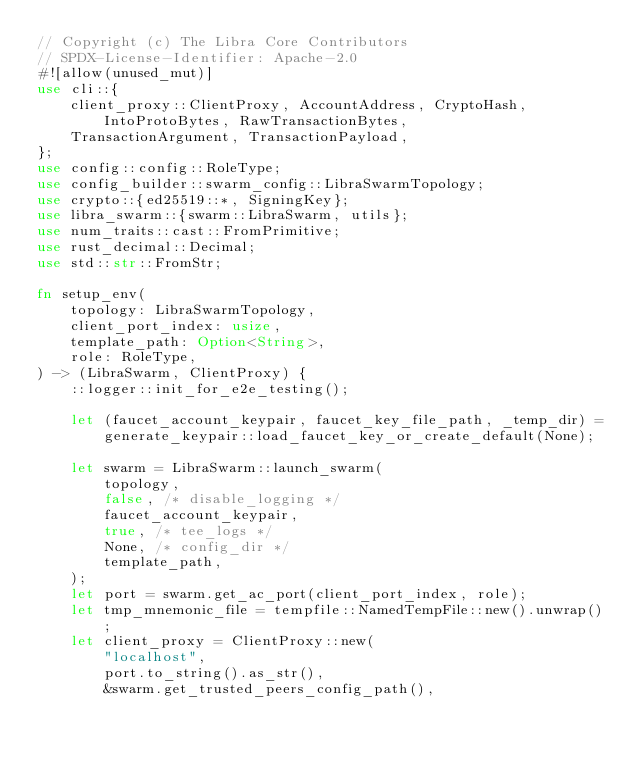<code> <loc_0><loc_0><loc_500><loc_500><_Rust_>// Copyright (c) The Libra Core Contributors
// SPDX-License-Identifier: Apache-2.0
#![allow(unused_mut)]
use cli::{
    client_proxy::ClientProxy, AccountAddress, CryptoHash, IntoProtoBytes, RawTransactionBytes,
    TransactionArgument, TransactionPayload,
};
use config::config::RoleType;
use config_builder::swarm_config::LibraSwarmTopology;
use crypto::{ed25519::*, SigningKey};
use libra_swarm::{swarm::LibraSwarm, utils};
use num_traits::cast::FromPrimitive;
use rust_decimal::Decimal;
use std::str::FromStr;

fn setup_env(
    topology: LibraSwarmTopology,
    client_port_index: usize,
    template_path: Option<String>,
    role: RoleType,
) -> (LibraSwarm, ClientProxy) {
    ::logger::init_for_e2e_testing();

    let (faucet_account_keypair, faucet_key_file_path, _temp_dir) =
        generate_keypair::load_faucet_key_or_create_default(None);

    let swarm = LibraSwarm::launch_swarm(
        topology,
        false, /* disable_logging */
        faucet_account_keypair,
        true, /* tee_logs */
        None, /* config_dir */
        template_path,
    );
    let port = swarm.get_ac_port(client_port_index, role);
    let tmp_mnemonic_file = tempfile::NamedTempFile::new().unwrap();
    let client_proxy = ClientProxy::new(
        "localhost",
        port.to_string().as_str(),
        &swarm.get_trusted_peers_config_path(),</code> 